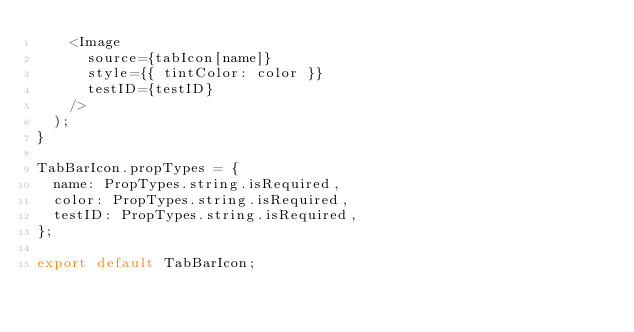<code> <loc_0><loc_0><loc_500><loc_500><_JavaScript_>    <Image
      source={tabIcon[name]}
      style={{ tintColor: color }}
      testID={testID}
    />
  );
}

TabBarIcon.propTypes = {
  name: PropTypes.string.isRequired,
  color: PropTypes.string.isRequired,
  testID: PropTypes.string.isRequired,
};

export default TabBarIcon;
</code> 